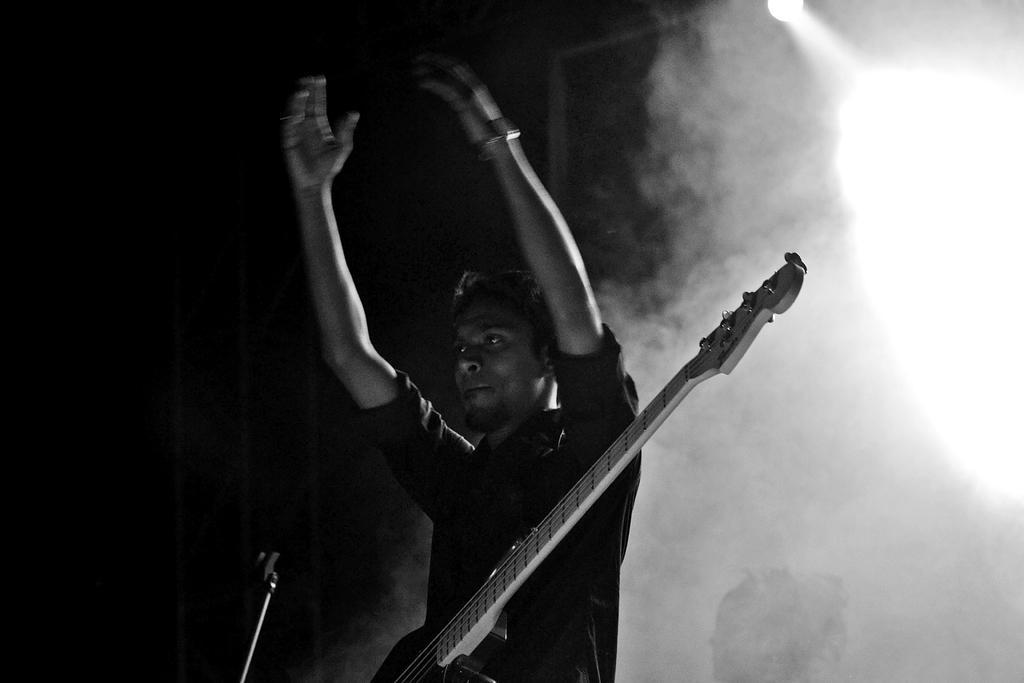Describe this image in one or two sentences. Background of the picture is very dark and here we can see smoke. In Front of the picture we can see a man standing in front of a mike. It's a guitar and we can see his hands are in the air. 